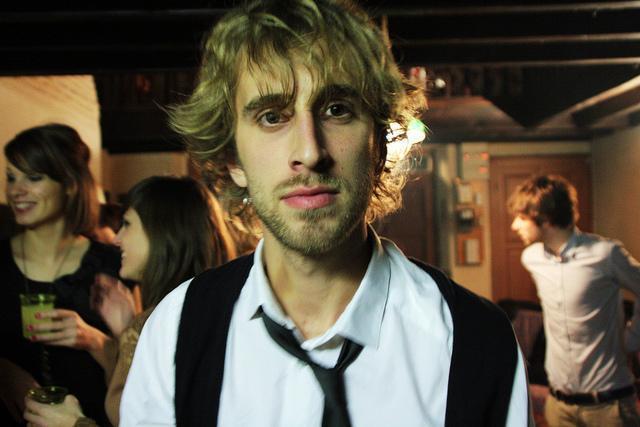How many people are there?
Give a very brief answer. 4. How many chairs are visible?
Give a very brief answer. 0. 